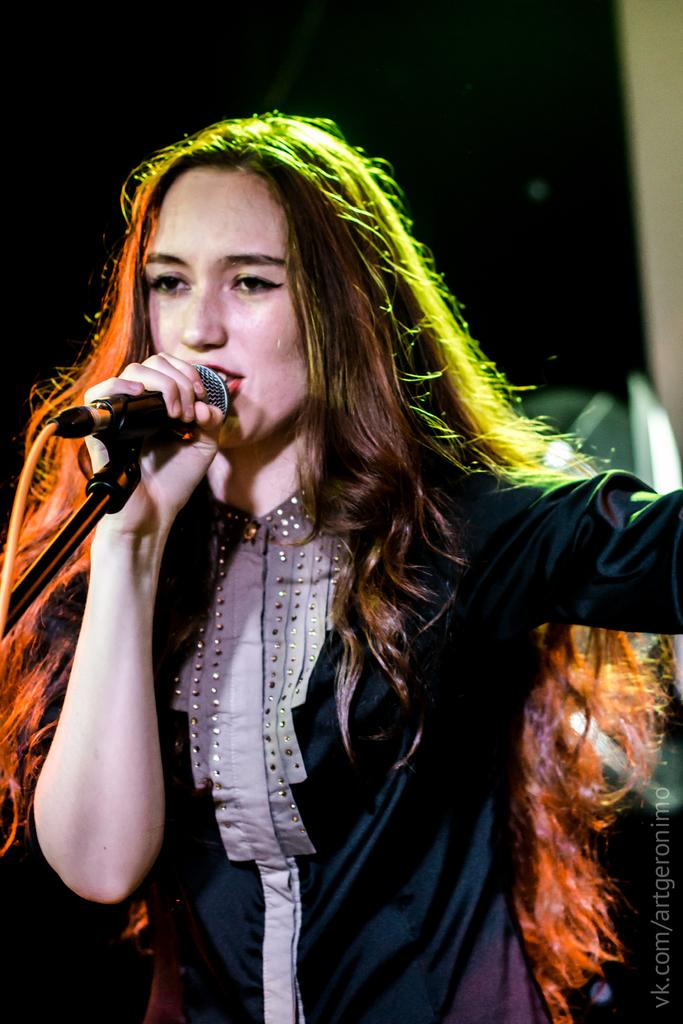Who is the main subject in the image? There is a woman in the image. What is the woman holding in the image? The woman is holding a microphone. What is the woman doing in the image? The woman is speaking, as indicated by her mouth being open. What type of apple is the woman holding in the image? There is no apple present in the image; the woman is holding a microphone. Is the woman wearing a coat in the image? The provided facts do not mention a coat, so we cannot determine if the woman is wearing one. --- 